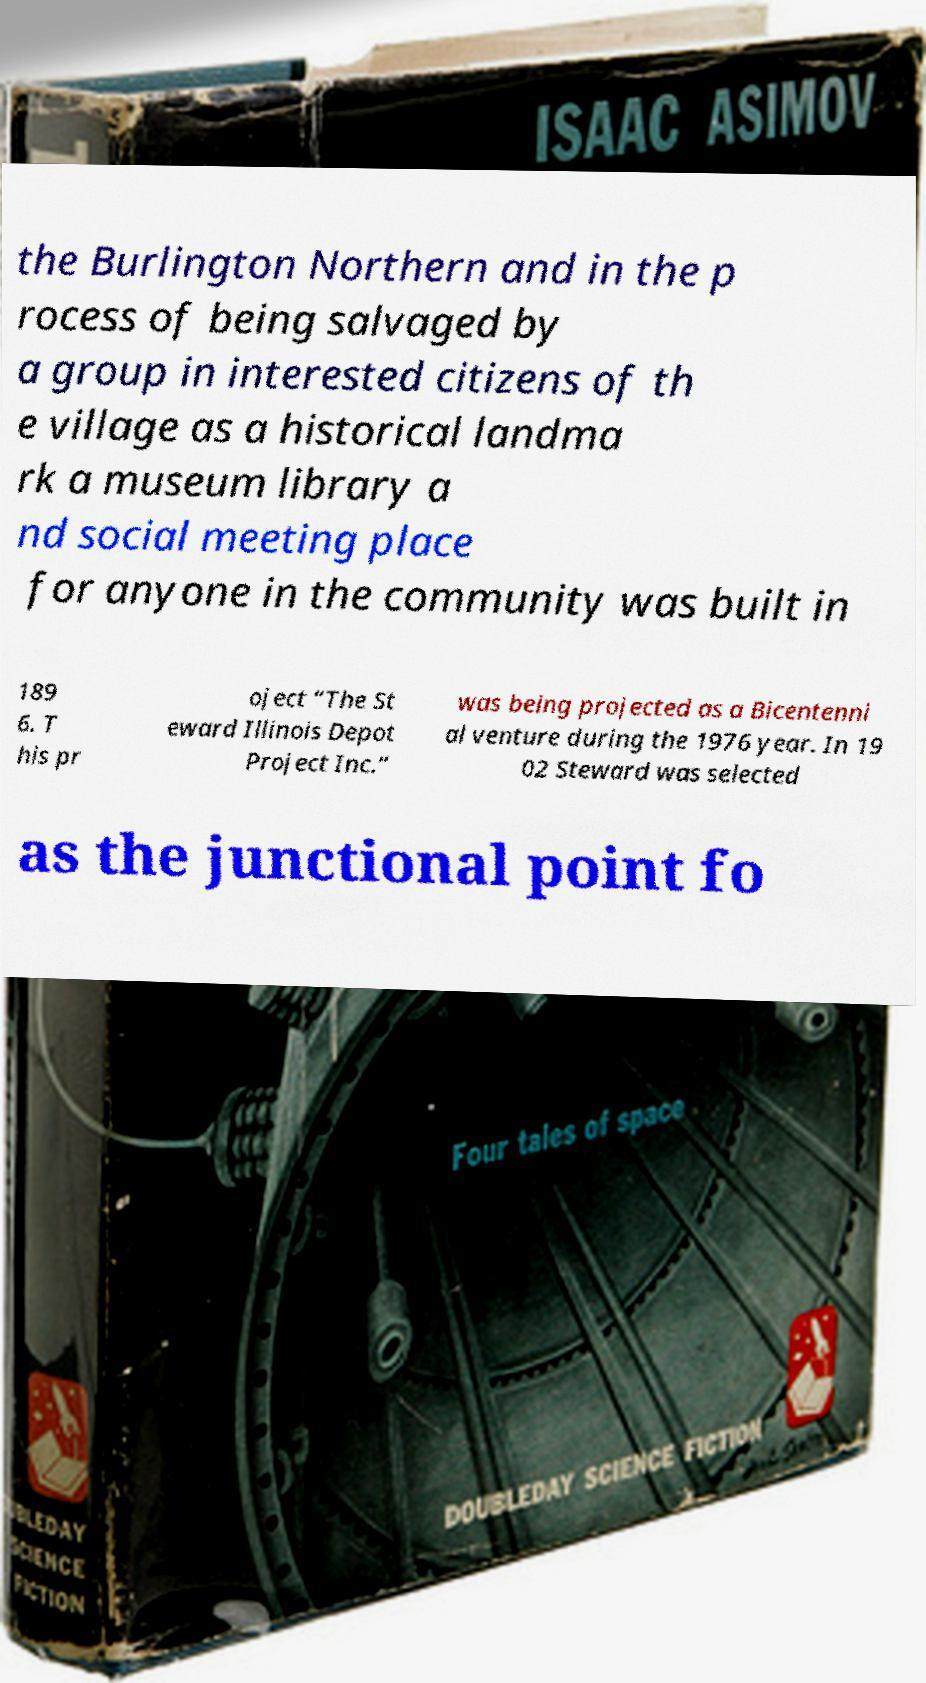Please identify and transcribe the text found in this image. the Burlington Northern and in the p rocess of being salvaged by a group in interested citizens of th e village as a historical landma rk a museum library a nd social meeting place for anyone in the community was built in 189 6. T his pr oject “The St eward Illinois Depot Project Inc.” was being projected as a Bicentenni al venture during the 1976 year. In 19 02 Steward was selected as the junctional point fo 